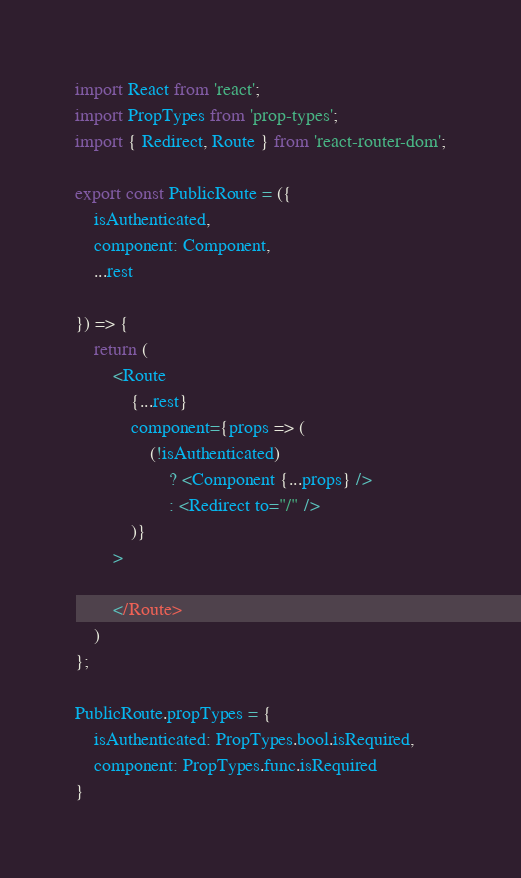<code> <loc_0><loc_0><loc_500><loc_500><_JavaScript_>import React from 'react';
import PropTypes from 'prop-types';
import { Redirect, Route } from 'react-router-dom';

export const PublicRoute = ({
    isAuthenticated,
    component: Component,
    ...rest

}) => {
    return (
        <Route
            {...rest}
            component={props => (
                (!isAuthenticated)
                    ? <Component {...props} />
                    : <Redirect to="/" />
            )}
        >

        </Route>
    )
};

PublicRoute.propTypes = {
    isAuthenticated: PropTypes.bool.isRequired,
    component: PropTypes.func.isRequired
}</code> 